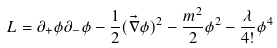<formula> <loc_0><loc_0><loc_500><loc_500>L = \partial _ { + } \phi \partial _ { - } \phi - \frac { 1 } { 2 } ( \vec { \nabla } \phi ) ^ { 2 } - \frac { m ^ { 2 } } { 2 } \phi ^ { 2 } - \frac { \lambda } { 4 ! } \phi ^ { 4 }</formula> 